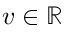<formula> <loc_0><loc_0><loc_500><loc_500>v \in \mathbb { R }</formula> 